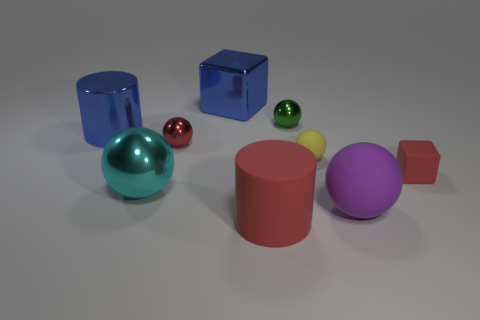The other small thing that is made of the same material as the green object is what color?
Your answer should be compact. Red. Is the number of big cyan metallic cubes less than the number of yellow matte spheres?
Offer a terse response. Yes. What is the big sphere that is on the left side of the tiny red thing left of the red matte object left of the matte cube made of?
Offer a very short reply. Metal. What is the tiny yellow object made of?
Offer a very short reply. Rubber. Does the block that is left of the big red rubber object have the same color as the big cylinder behind the large cyan metallic thing?
Your response must be concise. Yes. Are there more red blocks than large yellow matte balls?
Keep it short and to the point. Yes. What number of small shiny balls have the same color as the large rubber ball?
Provide a succinct answer. 0. What color is the tiny rubber object that is the same shape as the large purple matte object?
Keep it short and to the point. Yellow. What is the object that is both on the left side of the tiny red sphere and in front of the matte block made of?
Your response must be concise. Metal. Is the small red thing that is on the right side of the big red matte cylinder made of the same material as the large blue thing in front of the blue block?
Provide a short and direct response. No. 